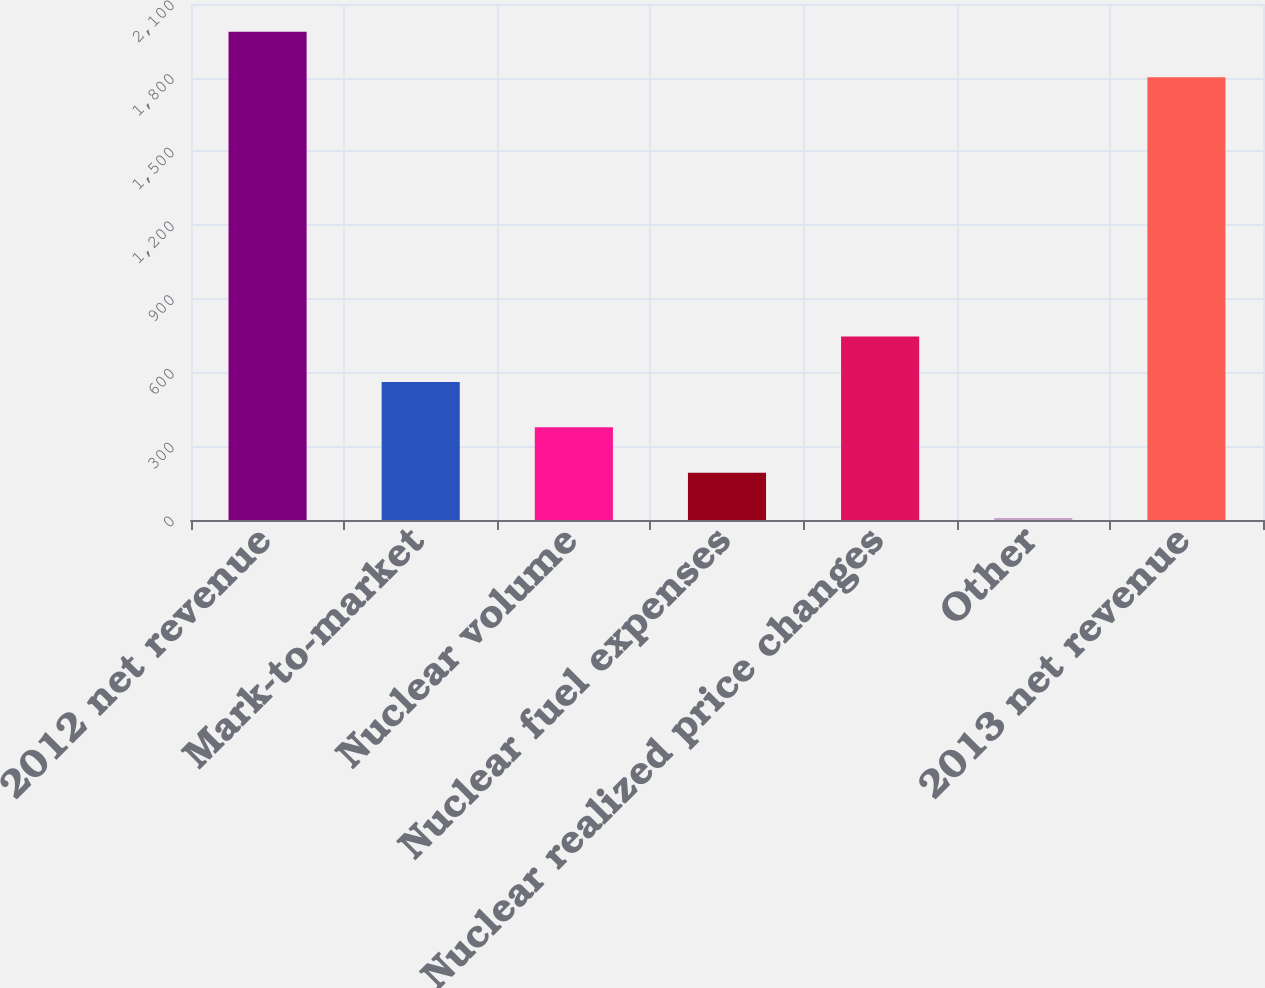<chart> <loc_0><loc_0><loc_500><loc_500><bar_chart><fcel>2012 net revenue<fcel>Mark-to-market<fcel>Nuclear volume<fcel>Nuclear fuel expenses<fcel>Nuclear realized price changes<fcel>Other<fcel>2013 net revenue<nl><fcel>1986.6<fcel>561.8<fcel>377.2<fcel>192.6<fcel>746.4<fcel>8<fcel>1802<nl></chart> 